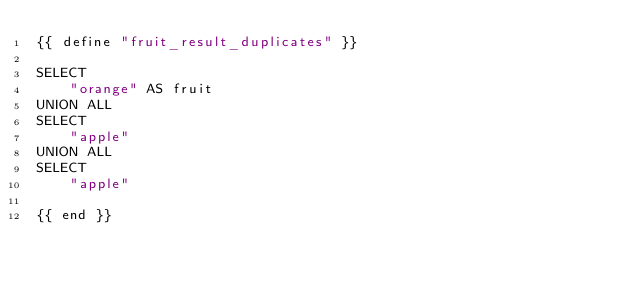<code> <loc_0><loc_0><loc_500><loc_500><_SQL_>{{ define "fruit_result_duplicates" }}

SELECT
    "orange" AS fruit
UNION ALL
SELECT
    "apple"
UNION ALL
SELECT
    "apple"

{{ end }}</code> 